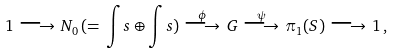<formula> <loc_0><loc_0><loc_500><loc_500>1 \, \longrightarrow \, N _ { 0 } \, ( = \, \int s \oplus \int s ) \, \stackrel { \phi } { \longrightarrow } \, G \, \stackrel { \psi } { \longrightarrow } \, \pi _ { 1 } ( S ) \, \longrightarrow \, 1 \, ,</formula> 